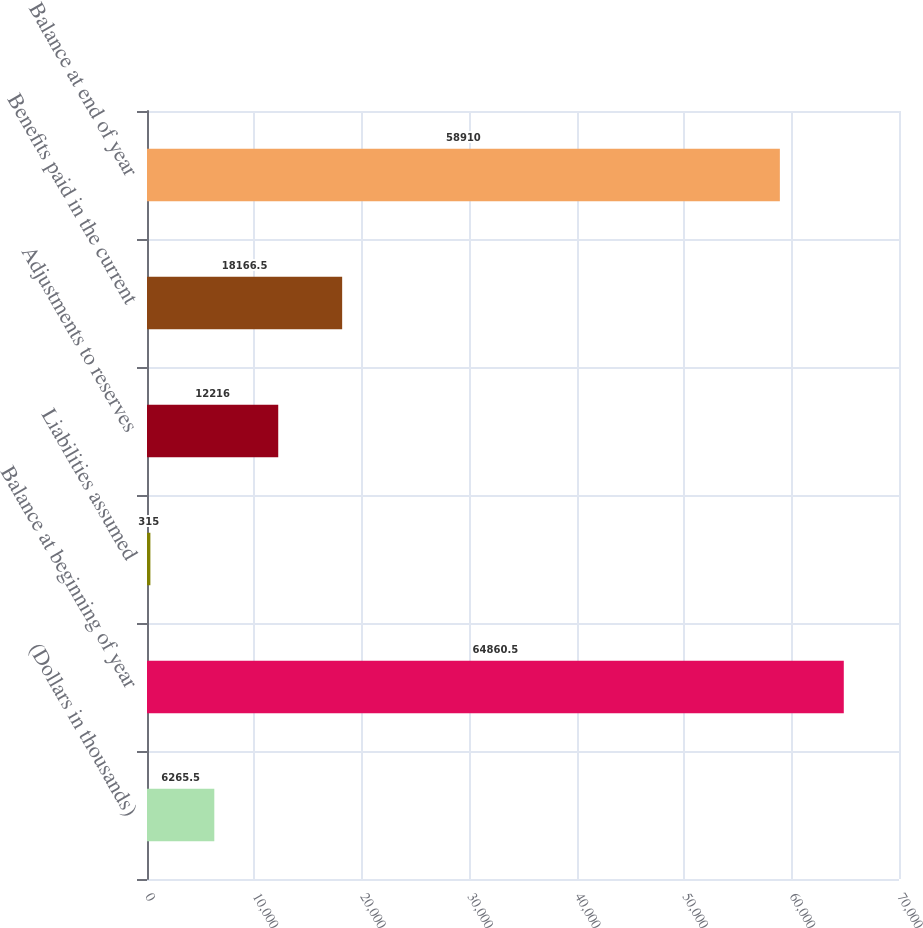<chart> <loc_0><loc_0><loc_500><loc_500><bar_chart><fcel>(Dollars in thousands)<fcel>Balance at beginning of year<fcel>Liabilities assumed<fcel>Adjustments to reserves<fcel>Benefits paid in the current<fcel>Balance at end of year<nl><fcel>6265.5<fcel>64860.5<fcel>315<fcel>12216<fcel>18166.5<fcel>58910<nl></chart> 